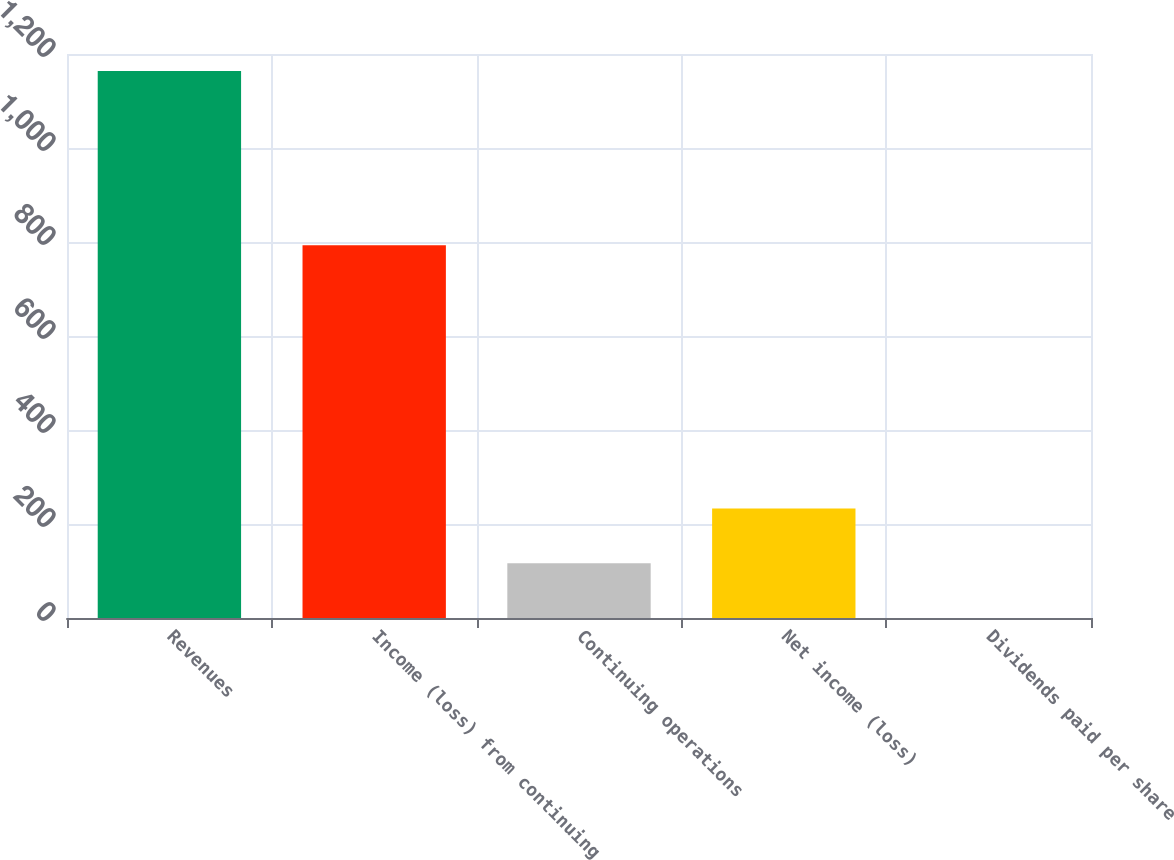<chart> <loc_0><loc_0><loc_500><loc_500><bar_chart><fcel>Revenues<fcel>Income (loss) from continuing<fcel>Continuing operations<fcel>Net income (loss)<fcel>Dividends paid per share<nl><fcel>1164<fcel>793<fcel>116.45<fcel>232.85<fcel>0.05<nl></chart> 